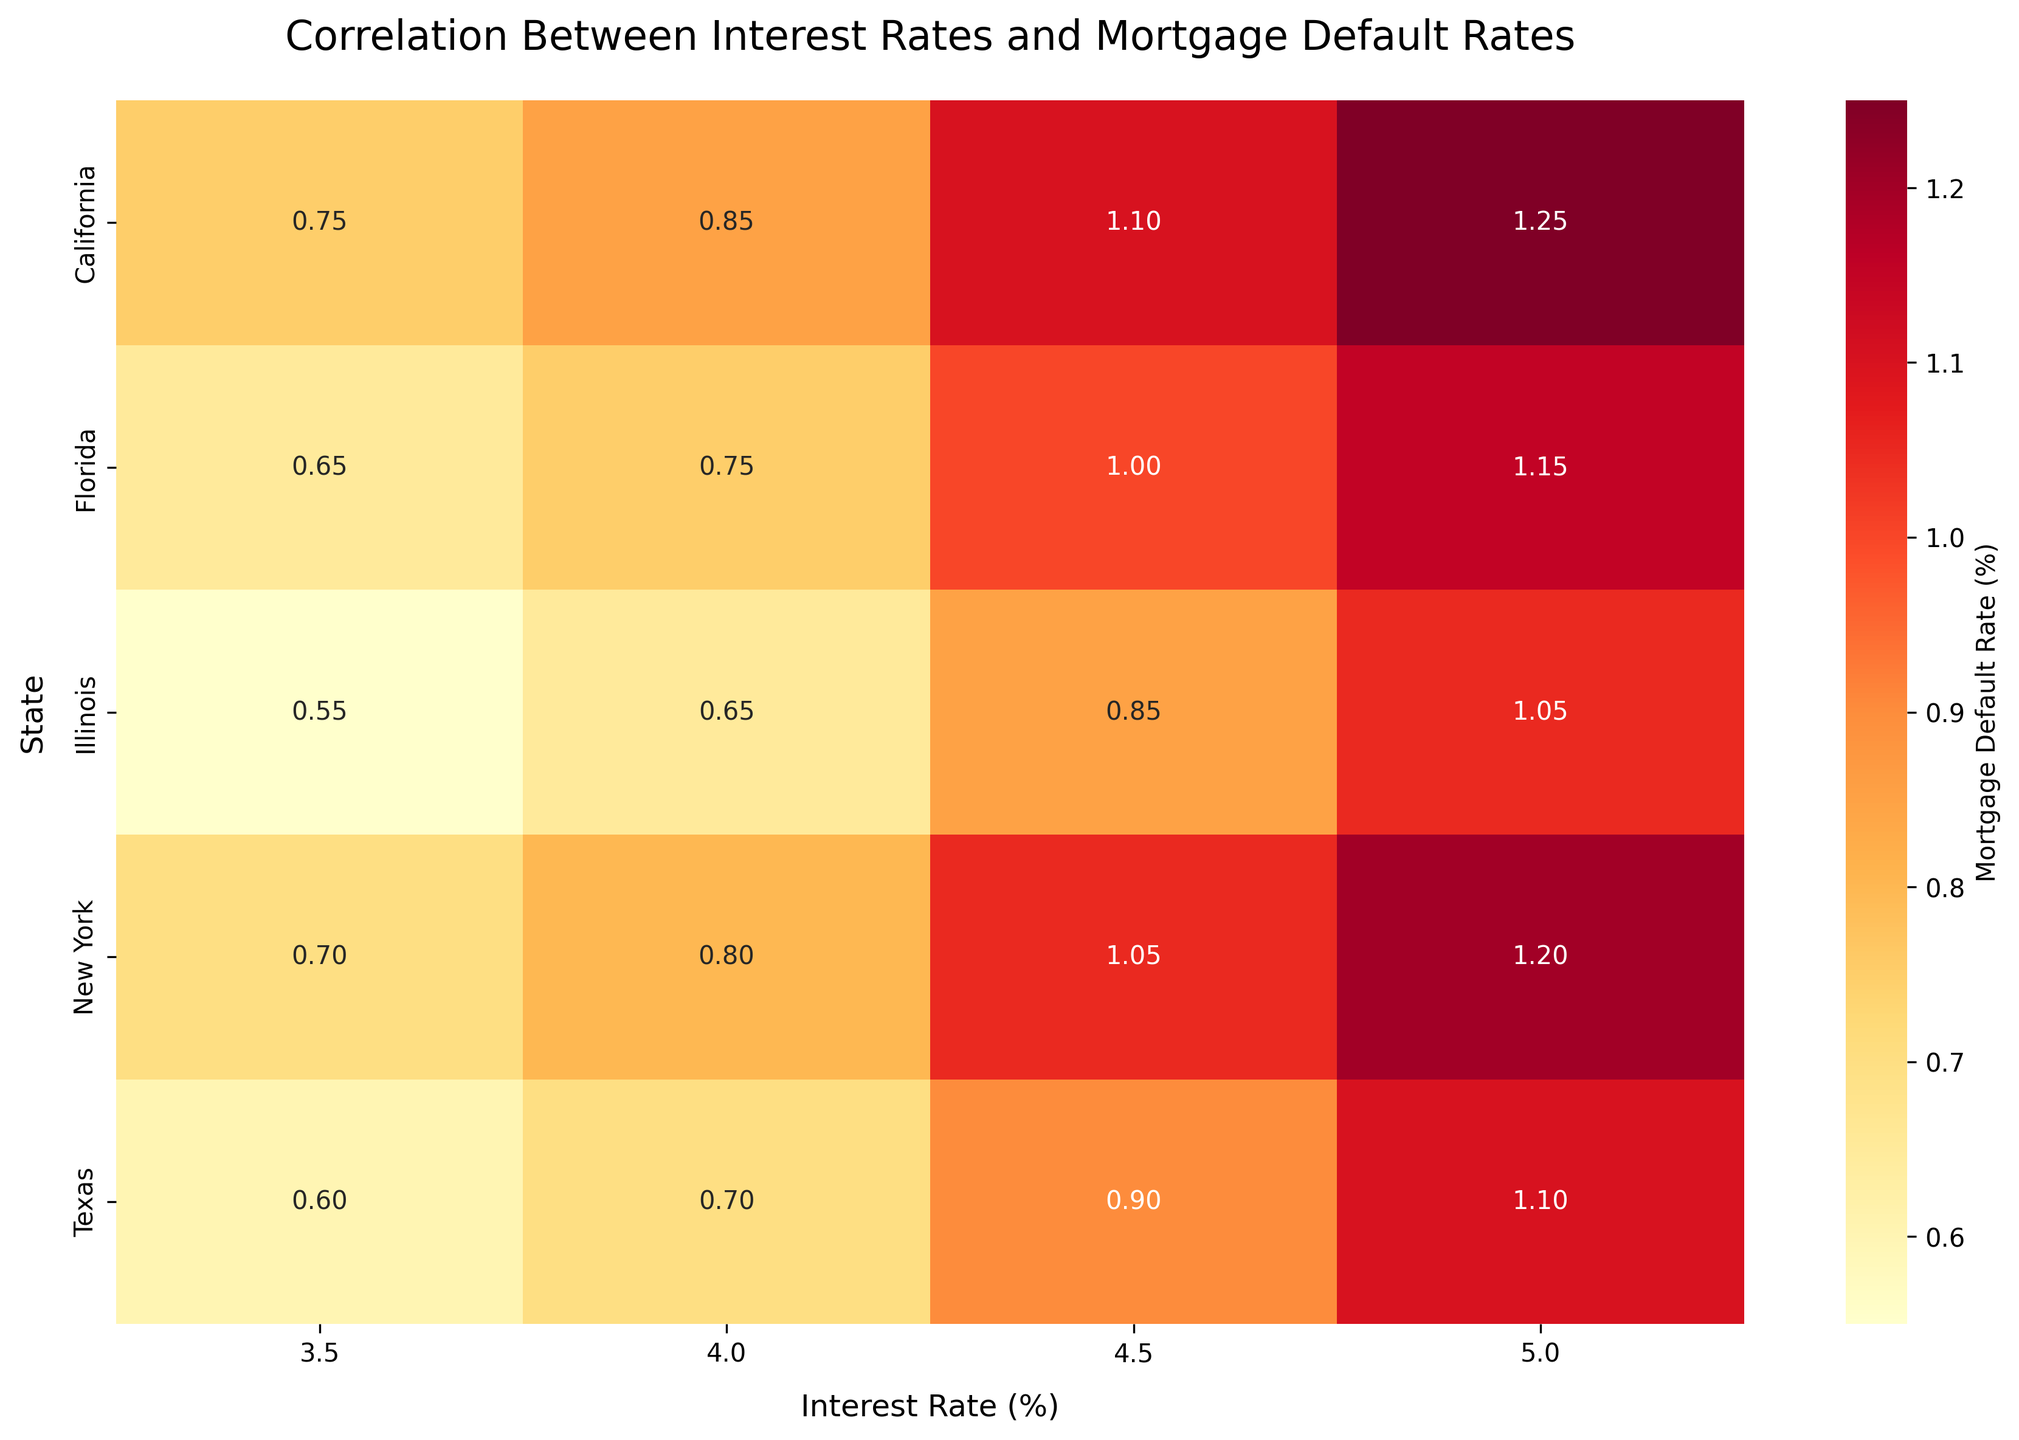What is the title of the heatmap? The title of the heatmap is displayed at the top of the figure. This explains the main focus of the visualization.
Answer: Correlation Between Interest Rates and Mortgage Default Rates What color is used to represent higher mortgage default rates in the heatmap? The heatmap uses colors to represent values, with warmer colors usually indicating higher values. In this figure, we see that deeper shades of orange/red represent higher mortgage default rates.
Answer: Orange/Red How does the mortgage default rate change for California as the interest rate increases from 3.5% to 5%? By following the row for California and comparing the values from left to right (3.5% to 5%), we see the mortgage default rate increasing. Specifically, it changes from 0.75 to 1.25.
Answer: Increases from 0.75 to 1.25 Which state has the lowest mortgage default rate at 3.5% interest? Looking at the columns labeled 3.5% interest rate and finding the smallest number, we see that Illinois has the lowest mortgage default rate at this interest rate, which is 0.55.
Answer: Illinois Comparing Texas and Florida at 4.5% interest rate, which state has a higher mortgage default rate and by how much? By comparing the values in the 4.5% interest rate column for Texas and Florida, we observe that Florida's rate is 1.00 while Texas's rate is 0.90. The difference is calculated as 1.00 - 0.90.
Answer: Florida, 0.10 higher Which state has the most stable (least varying) mortgage default rates across all interest rates? By examining the range (difference between maximum and minimum values) for each state across all interest rates, Illinois has the smallest range (1.05 - 0.55 = 0.50), indicating the most stability.
Answer: Illinois What is the average mortgage default rate in New York at all interest rates? Calculating the average requires summing all the values for New York (0.70, 0.80, 1.05, 1.20) and dividing by the number of interest rate increments (4). The sum is (0.70 + 0.80 + 1.05 + 1.20) = 3.75, and the average is 3.75/4.
Answer: 0.94 Which state exhibits the highest mortgage default rate at any interest rate, and what is the rate? By scanning the heatmap for the highest value across all states and interest rates, we see that California exhibits a mortgage default rate of 1.25 at a 5.0% interest rate.
Answer: California, 1.25 Is there any state where the mortgage default rate does not exceed 1.0 at any interest rate? By reviewing each state's row and checking if all the values are ≤ 1.0, we find that Illinois' mortgage default rates (0.55, 0.65, 0.85, 1.05) do at points exceed 1.0, so no state has all values below 1.0.
Answer: None What trend can you observe generally in mortgage default rates related to increases in interest rates? By observing most rows, a general trend is that mortgage default rates tend to increase as the interest rates rise in almost all states.
Answer: Rates tend to increase 